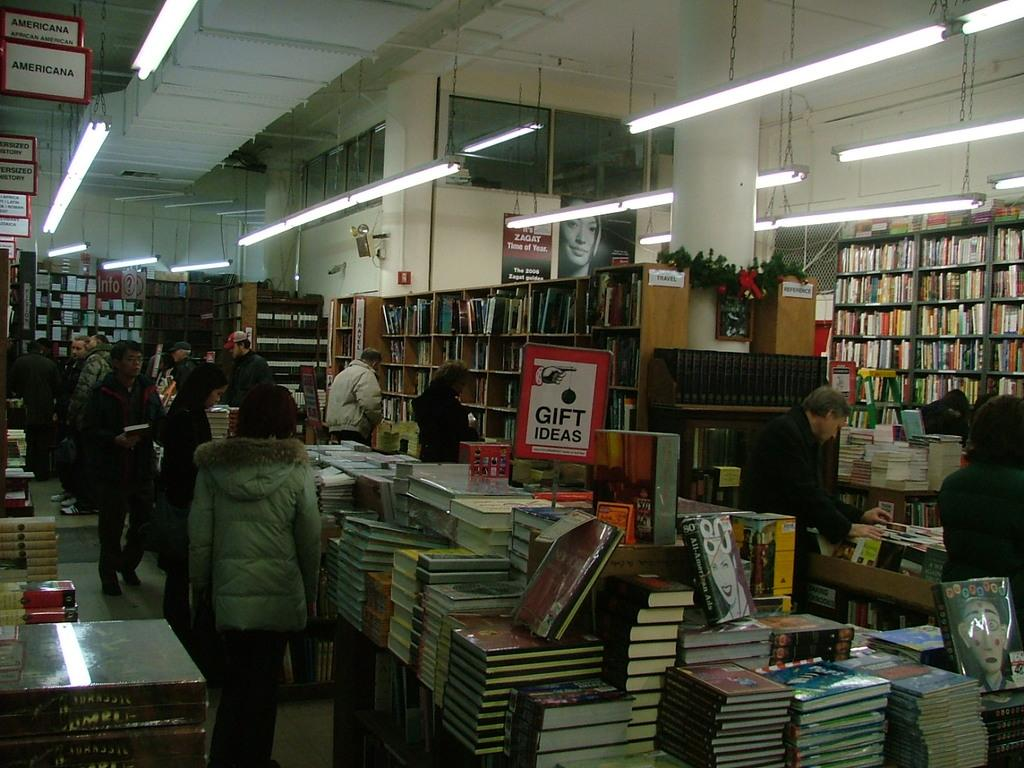<image>
Summarize the visual content of the image. The closest section of books is for Americana 